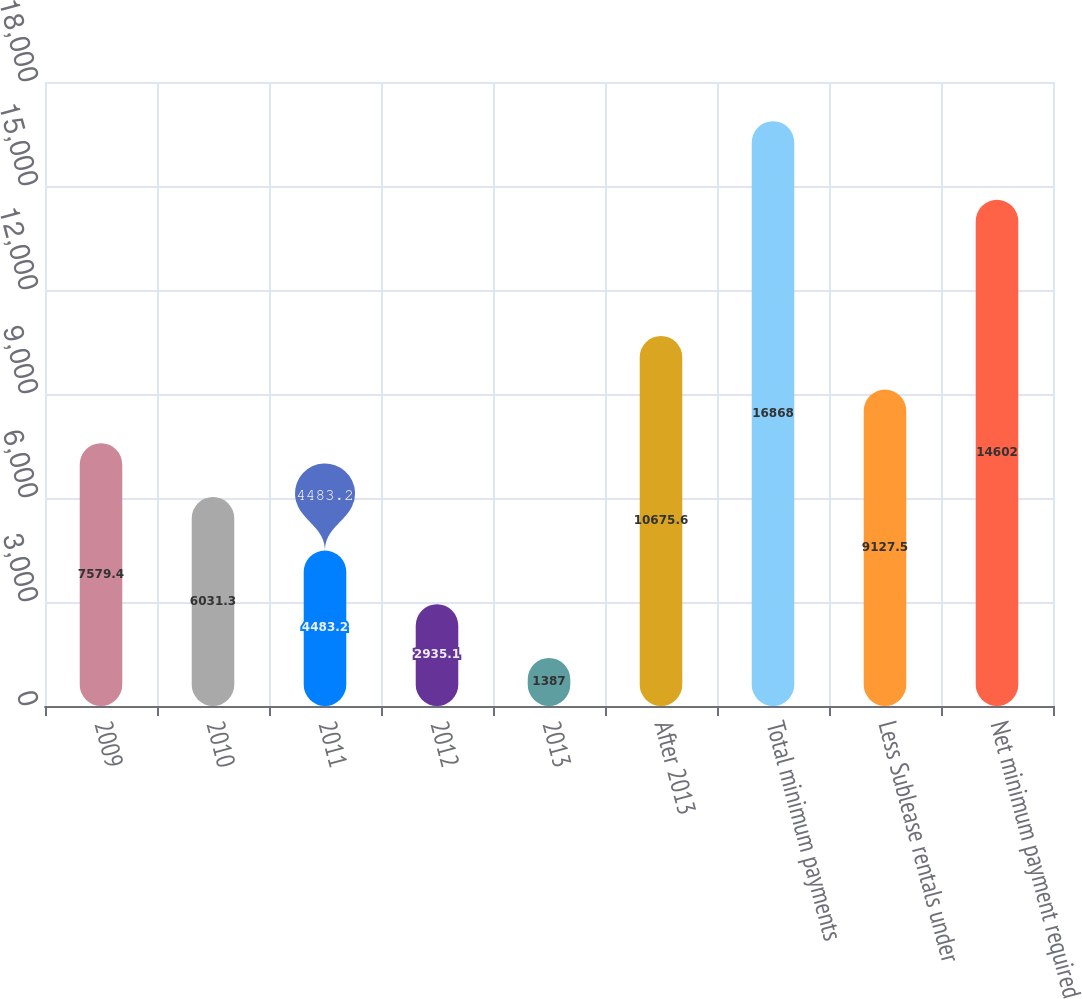Convert chart to OTSL. <chart><loc_0><loc_0><loc_500><loc_500><bar_chart><fcel>2009<fcel>2010<fcel>2011<fcel>2012<fcel>2013<fcel>After 2013<fcel>Total minimum payments<fcel>Less Sublease rentals under<fcel>Net minimum payment required<nl><fcel>7579.4<fcel>6031.3<fcel>4483.2<fcel>2935.1<fcel>1387<fcel>10675.6<fcel>16868<fcel>9127.5<fcel>14602<nl></chart> 